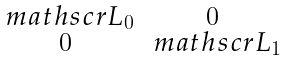Convert formula to latex. <formula><loc_0><loc_0><loc_500><loc_500>\begin{smallmatrix} \ m a t h s c r L _ { 0 } & 0 \\ 0 & \ m a t h s c r L _ { 1 } \end{smallmatrix}</formula> 